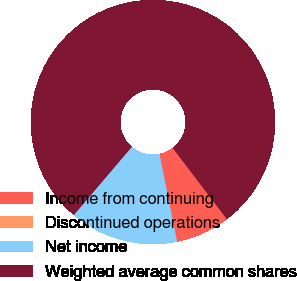Convert chart to OTSL. <chart><loc_0><loc_0><loc_500><loc_500><pie_chart><fcel>Income from continuing<fcel>Discontinued operations<fcel>Net income<fcel>Weighted average common shares<nl><fcel>7.19%<fcel>0.01%<fcel>14.38%<fcel>78.42%<nl></chart> 